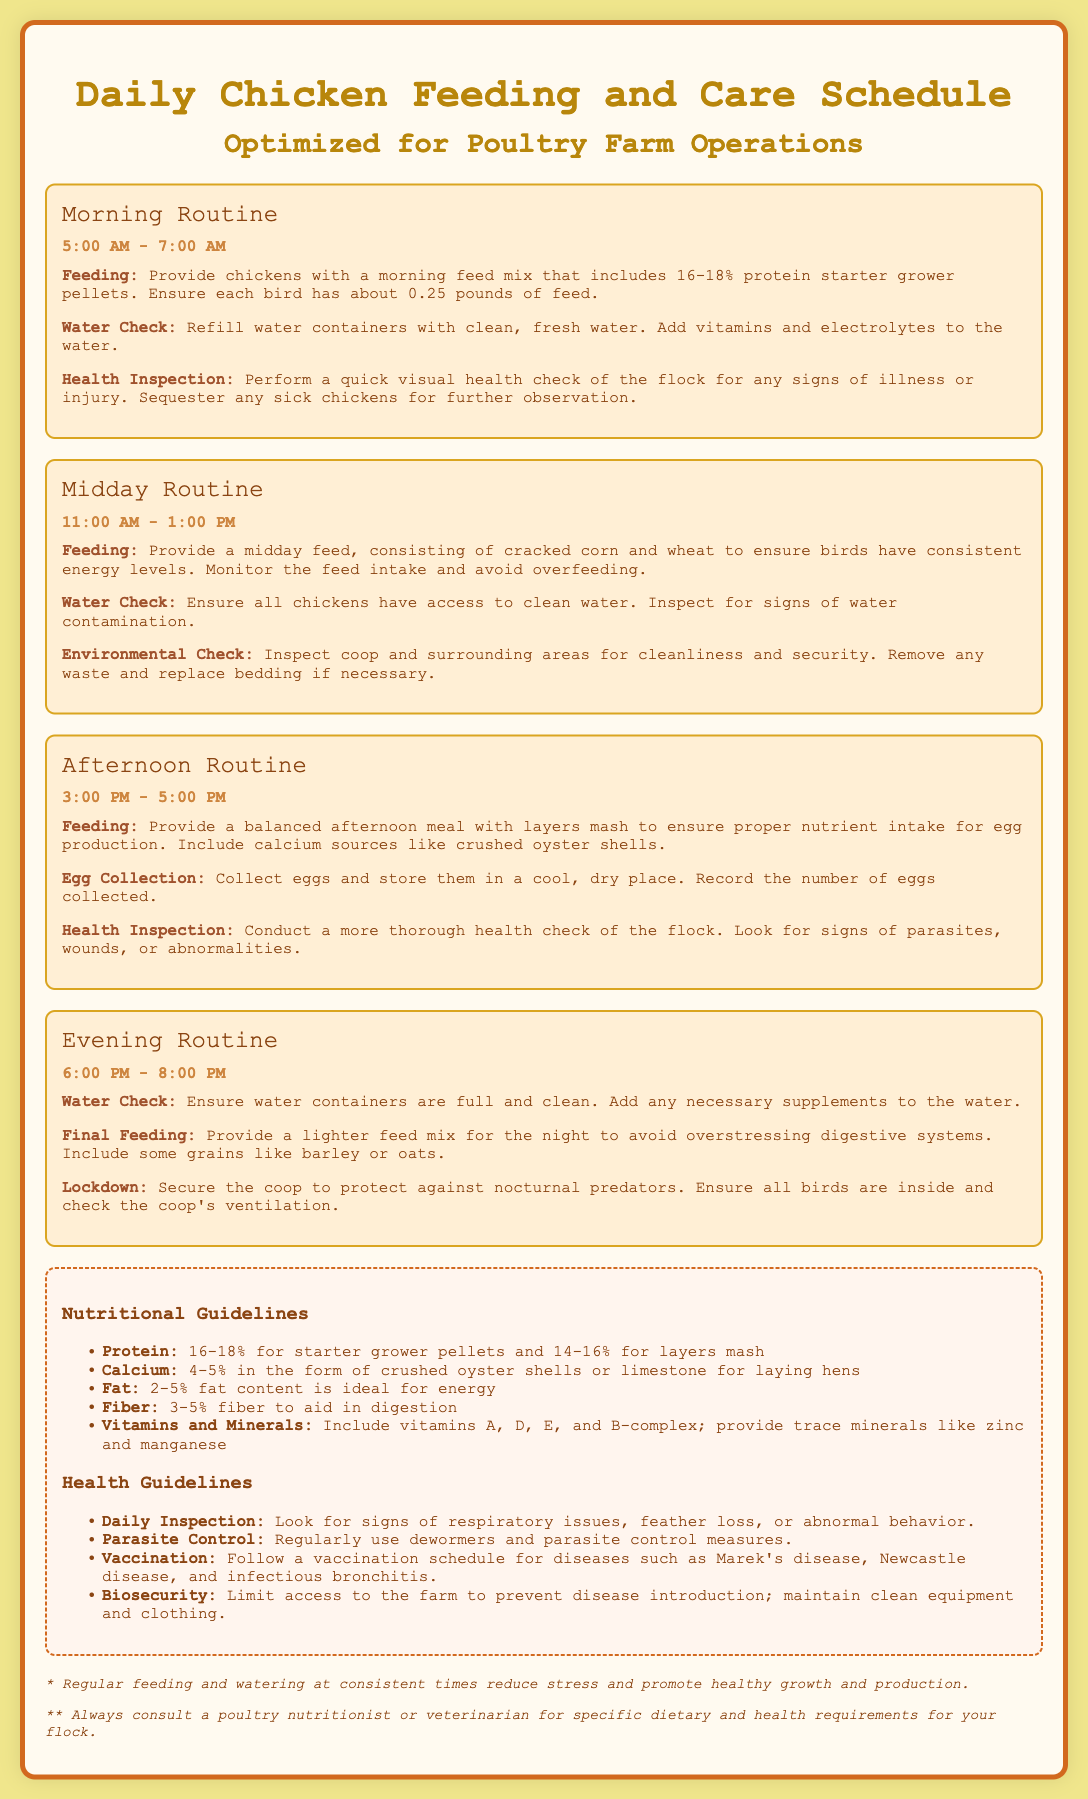what time is the morning feeding scheduled? The morning feeding is scheduled from 5:00 AM to 7:00 AM.
Answer: 5:00 AM - 7:00 AM what is the protein percentage for starter grower pellets? The protein percentage for starter grower pellets is 16-18%.
Answer: 16-18% what should be added to the water during the morning routine? During the morning routine, vitamins and electrolytes should be added to the water.
Answer: vitamins and electrolytes what activity is scheduled for 3:00 PM - 5:00 PM? The activities scheduled during this time include feeding with layers mash, egg collection, and health inspection.
Answer: Feeding, egg collection, health inspection what nutritional component is emphasized for laying hens? Crushed oyster shells are emphasized as a calcium source for laying hens.
Answer: crushed oyster shells what action is recommended for the evening routine? Securing the coop against nocturnal predators is the recommended action during the evening routine.
Answer: Secure the coop what is the main purpose of the midday feed? The main purpose of the midday feed is to ensure birds have consistent energy levels.
Answer: consistent energy levels how often should chickens be inspected for health? Chickens should have daily inspections for health.
Answer: Daily what is the ideal fat content for chicken feed? The ideal fat content for chicken feed is 2-5%.
Answer: 2-5% 